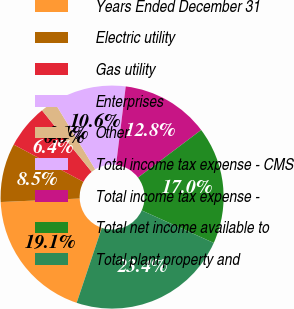Convert chart to OTSL. <chart><loc_0><loc_0><loc_500><loc_500><pie_chart><fcel>Years Ended December 31<fcel>Electric utility<fcel>Gas utility<fcel>Enterprises<fcel>Other<fcel>Total income tax expense - CMS<fcel>Total income tax expense -<fcel>Total net income available to<fcel>Total plant property and<nl><fcel>19.15%<fcel>8.51%<fcel>6.38%<fcel>0.0%<fcel>2.13%<fcel>10.64%<fcel>12.77%<fcel>17.02%<fcel>23.4%<nl></chart> 